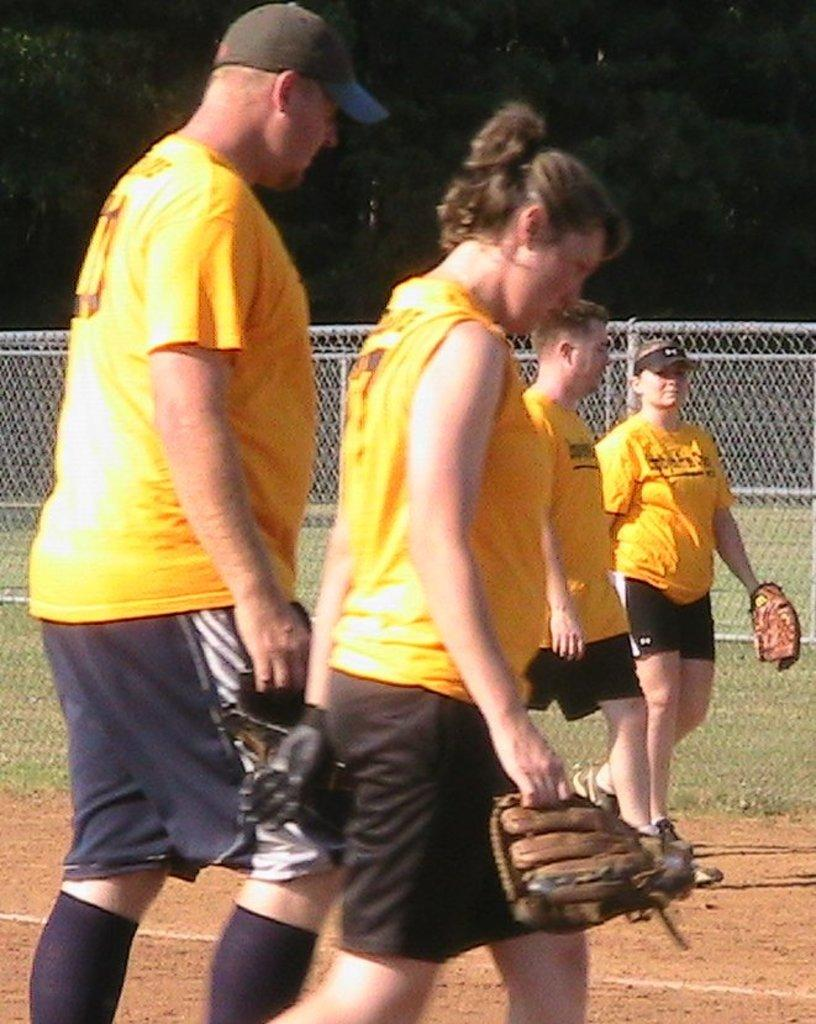What are the people in the image wearing? The people in the image are wearing yellow shirts. What is in the foreground of the image? There is sand in the foreground of the image. What type of fencing is present in the image? There is net fencing in the image. What can be seen in the background of the image? A: There are trees in the background of the image. What rhythm are the girls dancing to in the image? There are no girls present in the image, and no dancing or music is depicted. 